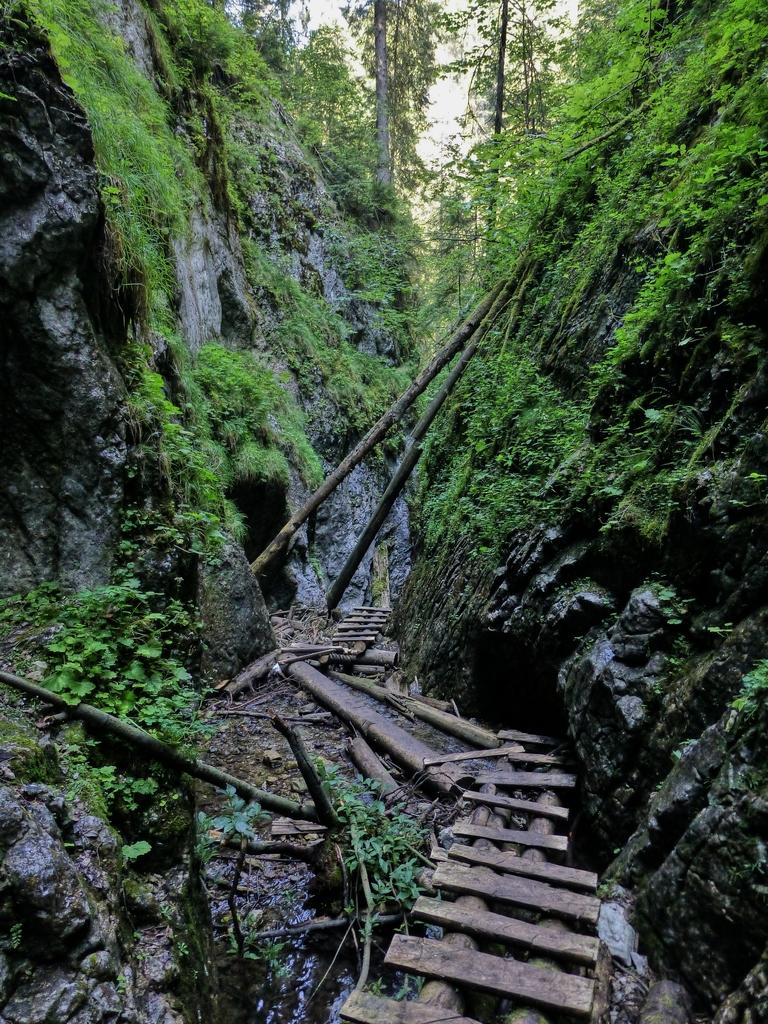What type of natural formation can be seen in the image? There are rocks in the image. What is growing on the rocks? Plants and algae are visible on the rocks. What other objects can be seen on the ground? There are wooden sticks on the ground. What can be seen in the background of the image? Trees are present in the background of the image. What type of alarm is ringing in the image? There is no alarm present in the image. Can you see anyone wearing a mask in the image? There are no people or masks visible in the image. 